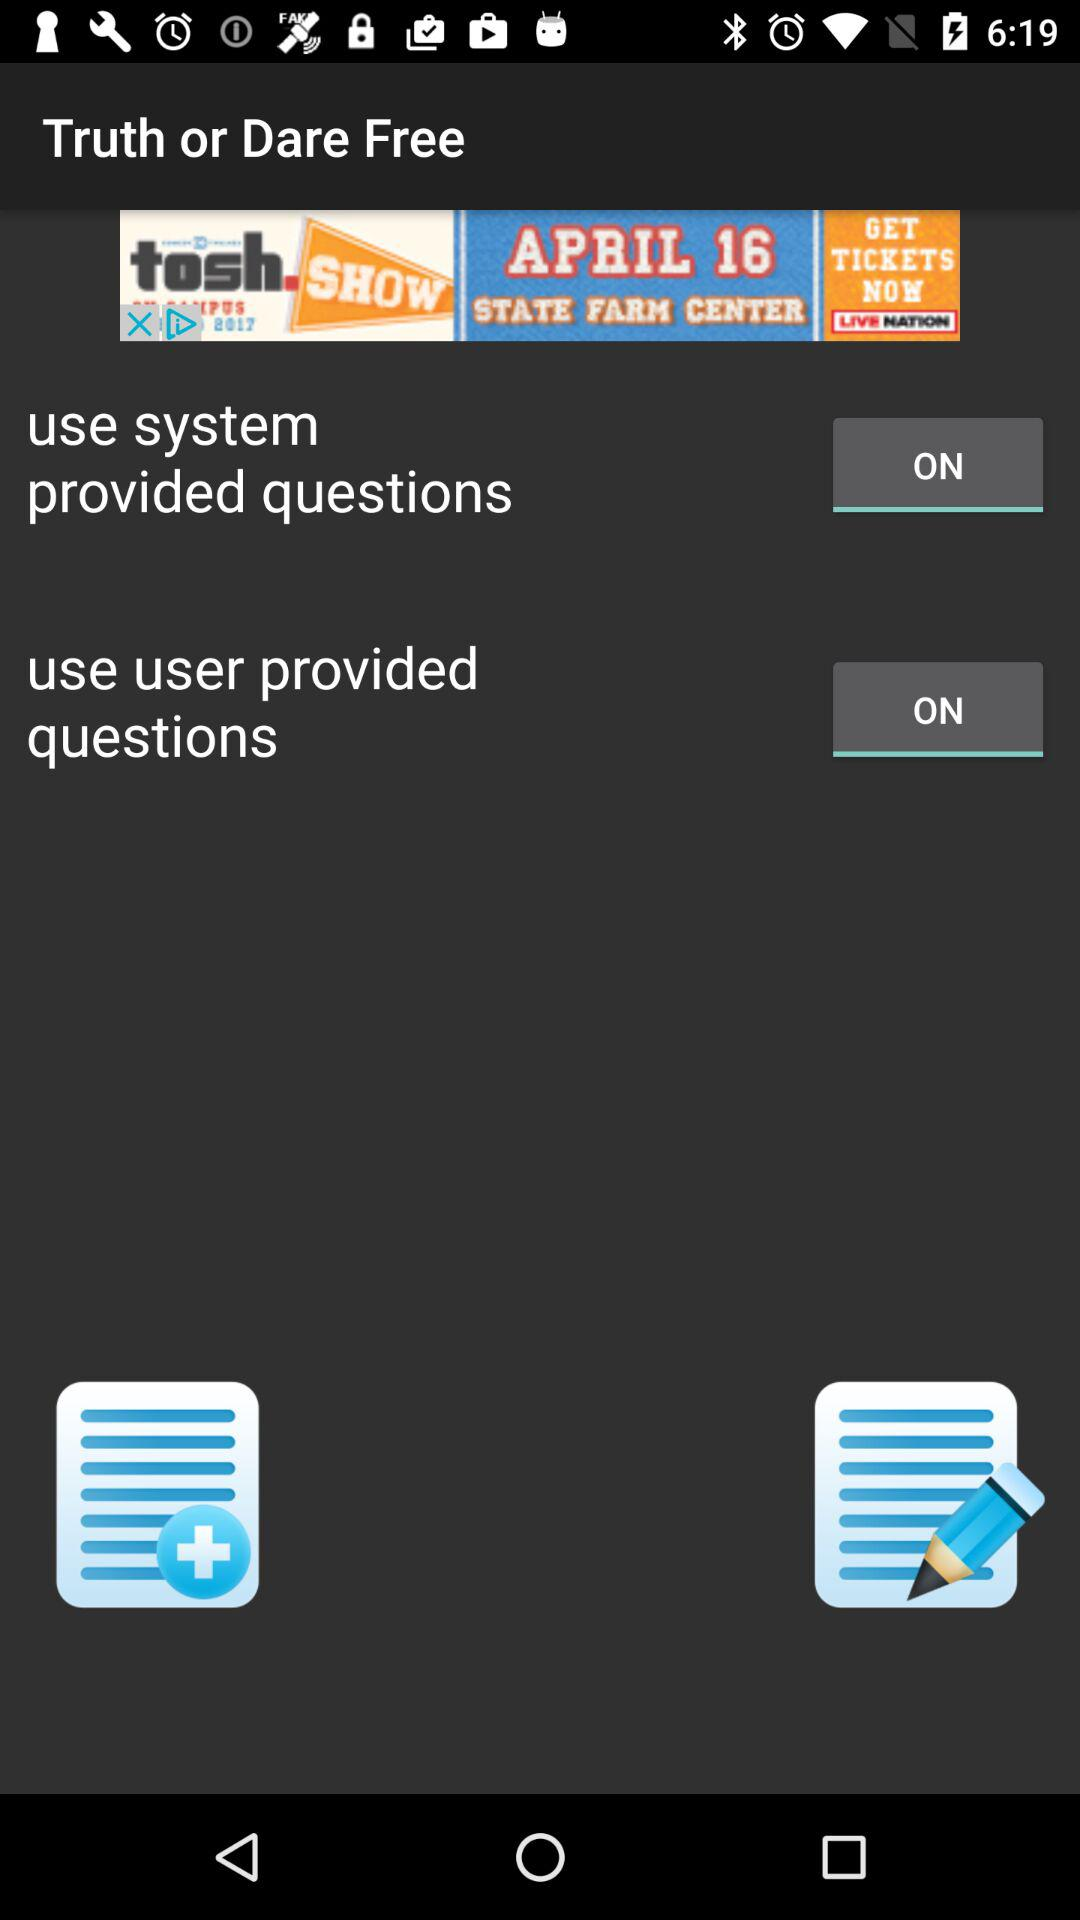What's the status for truth or dare free?
When the provided information is insufficient, respond with <no answer>. <no answer> 